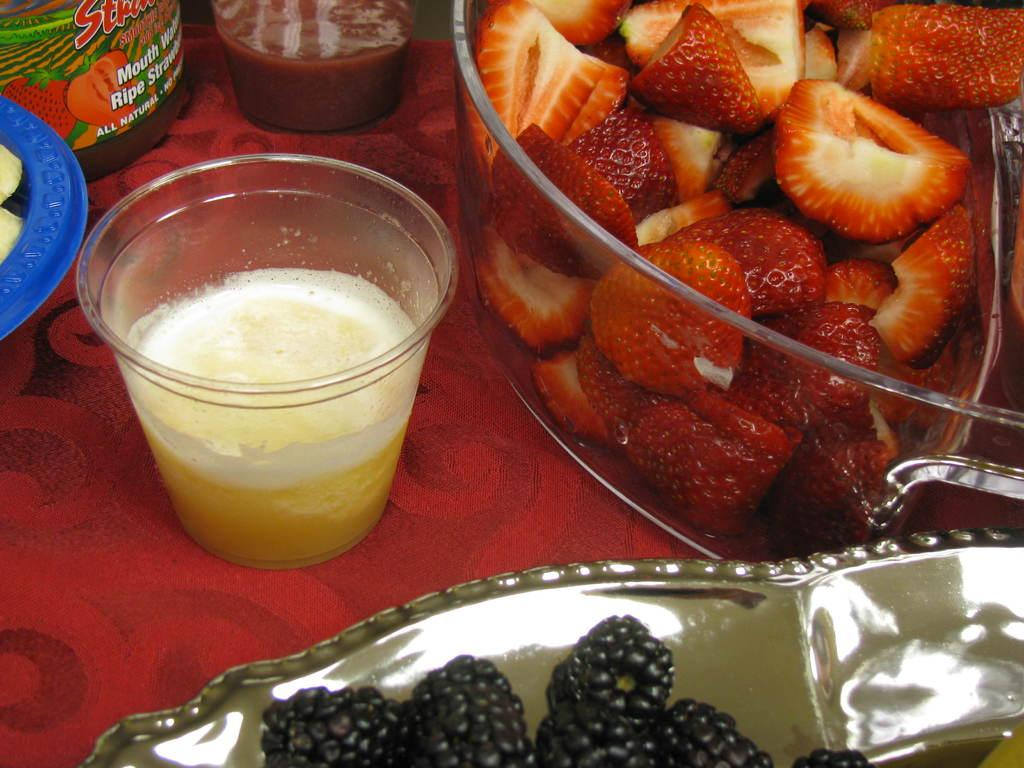What type of fruit can be found in the bowl in the image? There are pieces of strawberries in a bowl in the image. What other type of fruit is present in the image? There are blackberries in a plate in the image. What is the glass in the image filled with? The glass in the image contains liquid. What objects are placed on the surface in the image? There are containers placed on the surface in the image. How many feet are visible in the image? There are no feet visible in the image. What type of tool is used to jump in the image? There is no tool or action related to jumping present in the image. 